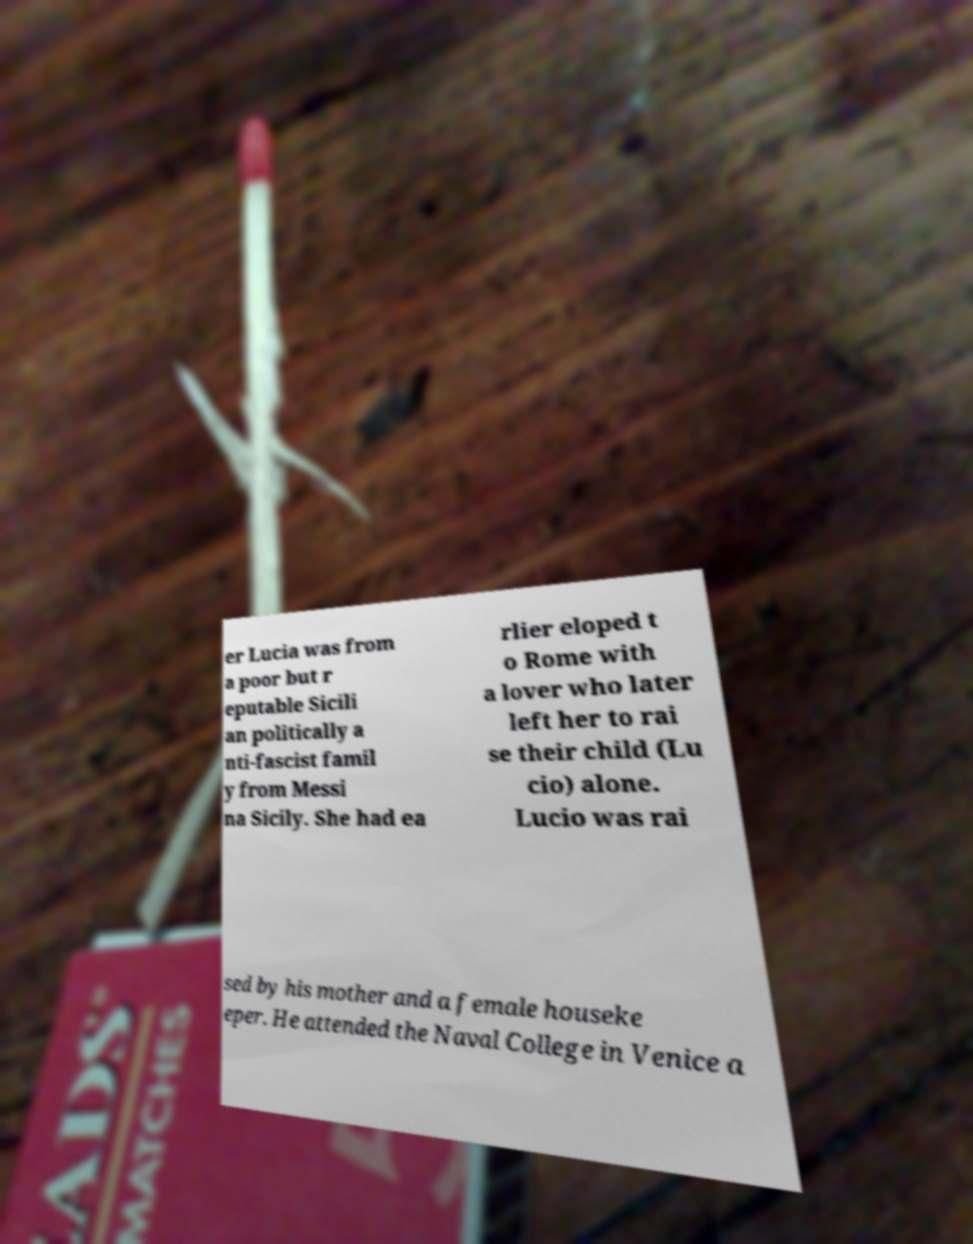Can you read and provide the text displayed in the image?This photo seems to have some interesting text. Can you extract and type it out for me? er Lucia was from a poor but r eputable Sicili an politically a nti-fascist famil y from Messi na Sicily. She had ea rlier eloped t o Rome with a lover who later left her to rai se their child (Lu cio) alone. Lucio was rai sed by his mother and a female houseke eper. He attended the Naval College in Venice a 